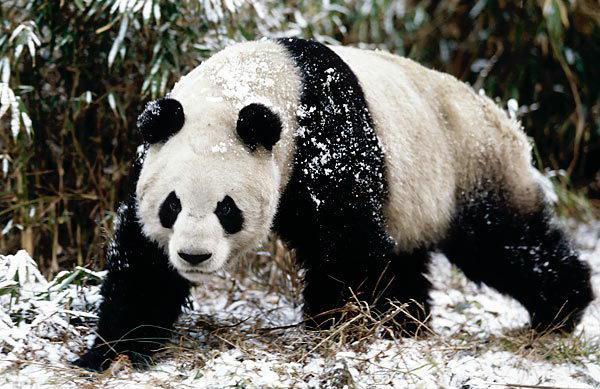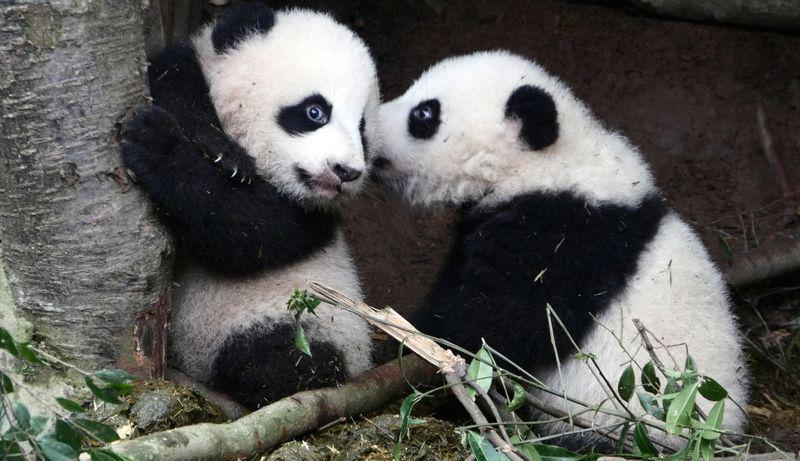The first image is the image on the left, the second image is the image on the right. Given the left and right images, does the statement "there are at most 2 pandas in the image pair" hold true? Answer yes or no. No. The first image is the image on the left, the second image is the image on the right. Evaluate the accuracy of this statement regarding the images: "There are three pandas". Is it true? Answer yes or no. Yes. 